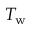<formula> <loc_0><loc_0><loc_500><loc_500>T _ { w }</formula> 